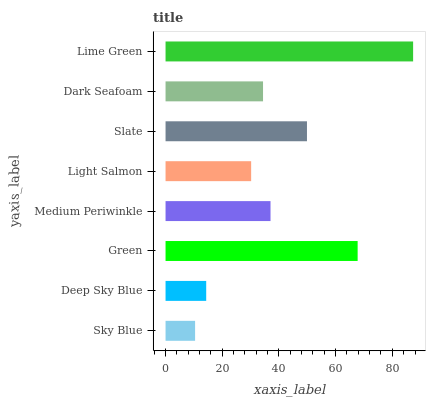Is Sky Blue the minimum?
Answer yes or no. Yes. Is Lime Green the maximum?
Answer yes or no. Yes. Is Deep Sky Blue the minimum?
Answer yes or no. No. Is Deep Sky Blue the maximum?
Answer yes or no. No. Is Deep Sky Blue greater than Sky Blue?
Answer yes or no. Yes. Is Sky Blue less than Deep Sky Blue?
Answer yes or no. Yes. Is Sky Blue greater than Deep Sky Blue?
Answer yes or no. No. Is Deep Sky Blue less than Sky Blue?
Answer yes or no. No. Is Medium Periwinkle the high median?
Answer yes or no. Yes. Is Dark Seafoam the low median?
Answer yes or no. Yes. Is Deep Sky Blue the high median?
Answer yes or no. No. Is Light Salmon the low median?
Answer yes or no. No. 